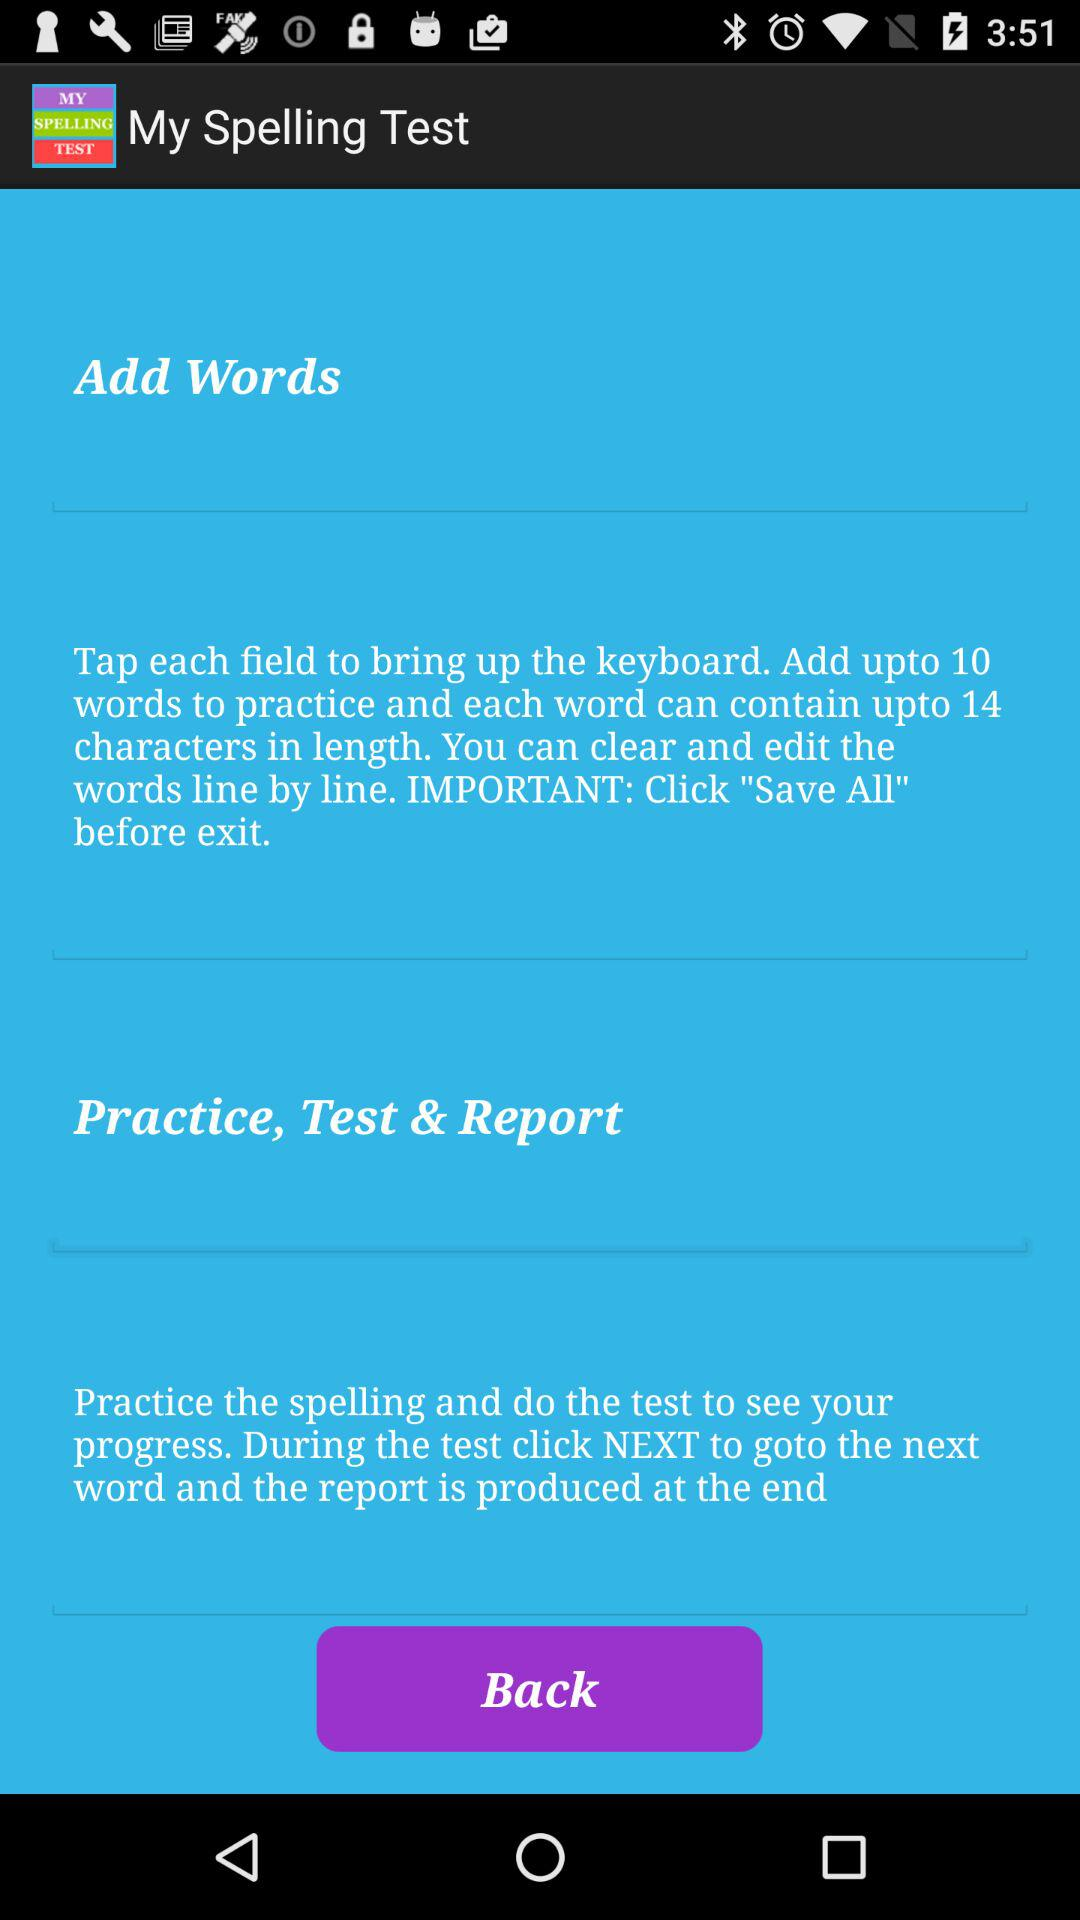What is the name of the application? The name of the application is "My Spelling Test". 